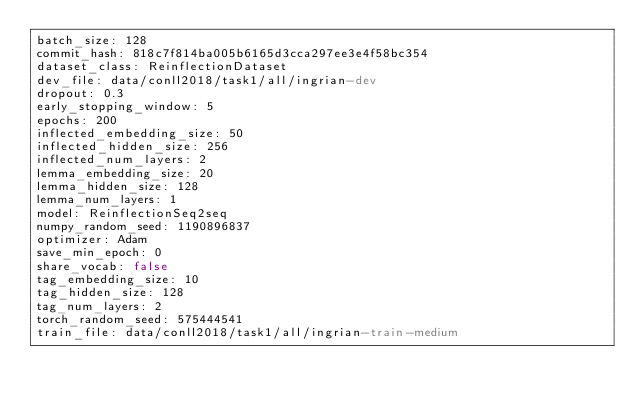Convert code to text. <code><loc_0><loc_0><loc_500><loc_500><_YAML_>batch_size: 128
commit_hash: 818c7f814ba005b6165d3cca297ee3e4f58bc354
dataset_class: ReinflectionDataset
dev_file: data/conll2018/task1/all/ingrian-dev
dropout: 0.3
early_stopping_window: 5
epochs: 200
inflected_embedding_size: 50
inflected_hidden_size: 256
inflected_num_layers: 2
lemma_embedding_size: 20
lemma_hidden_size: 128
lemma_num_layers: 1
model: ReinflectionSeq2seq
numpy_random_seed: 1190896837
optimizer: Adam
save_min_epoch: 0
share_vocab: false
tag_embedding_size: 10
tag_hidden_size: 128
tag_num_layers: 2
torch_random_seed: 575444541
train_file: data/conll2018/task1/all/ingrian-train-medium
</code> 